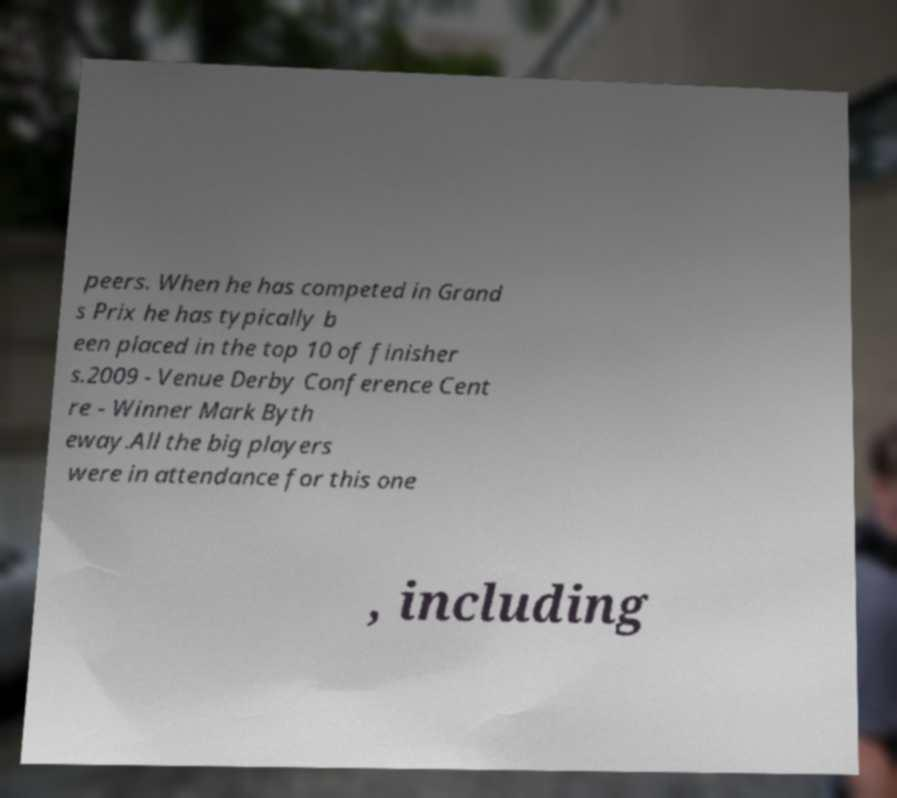Could you extract and type out the text from this image? peers. When he has competed in Grand s Prix he has typically b een placed in the top 10 of finisher s.2009 - Venue Derby Conference Cent re - Winner Mark Byth eway.All the big players were in attendance for this one , including 